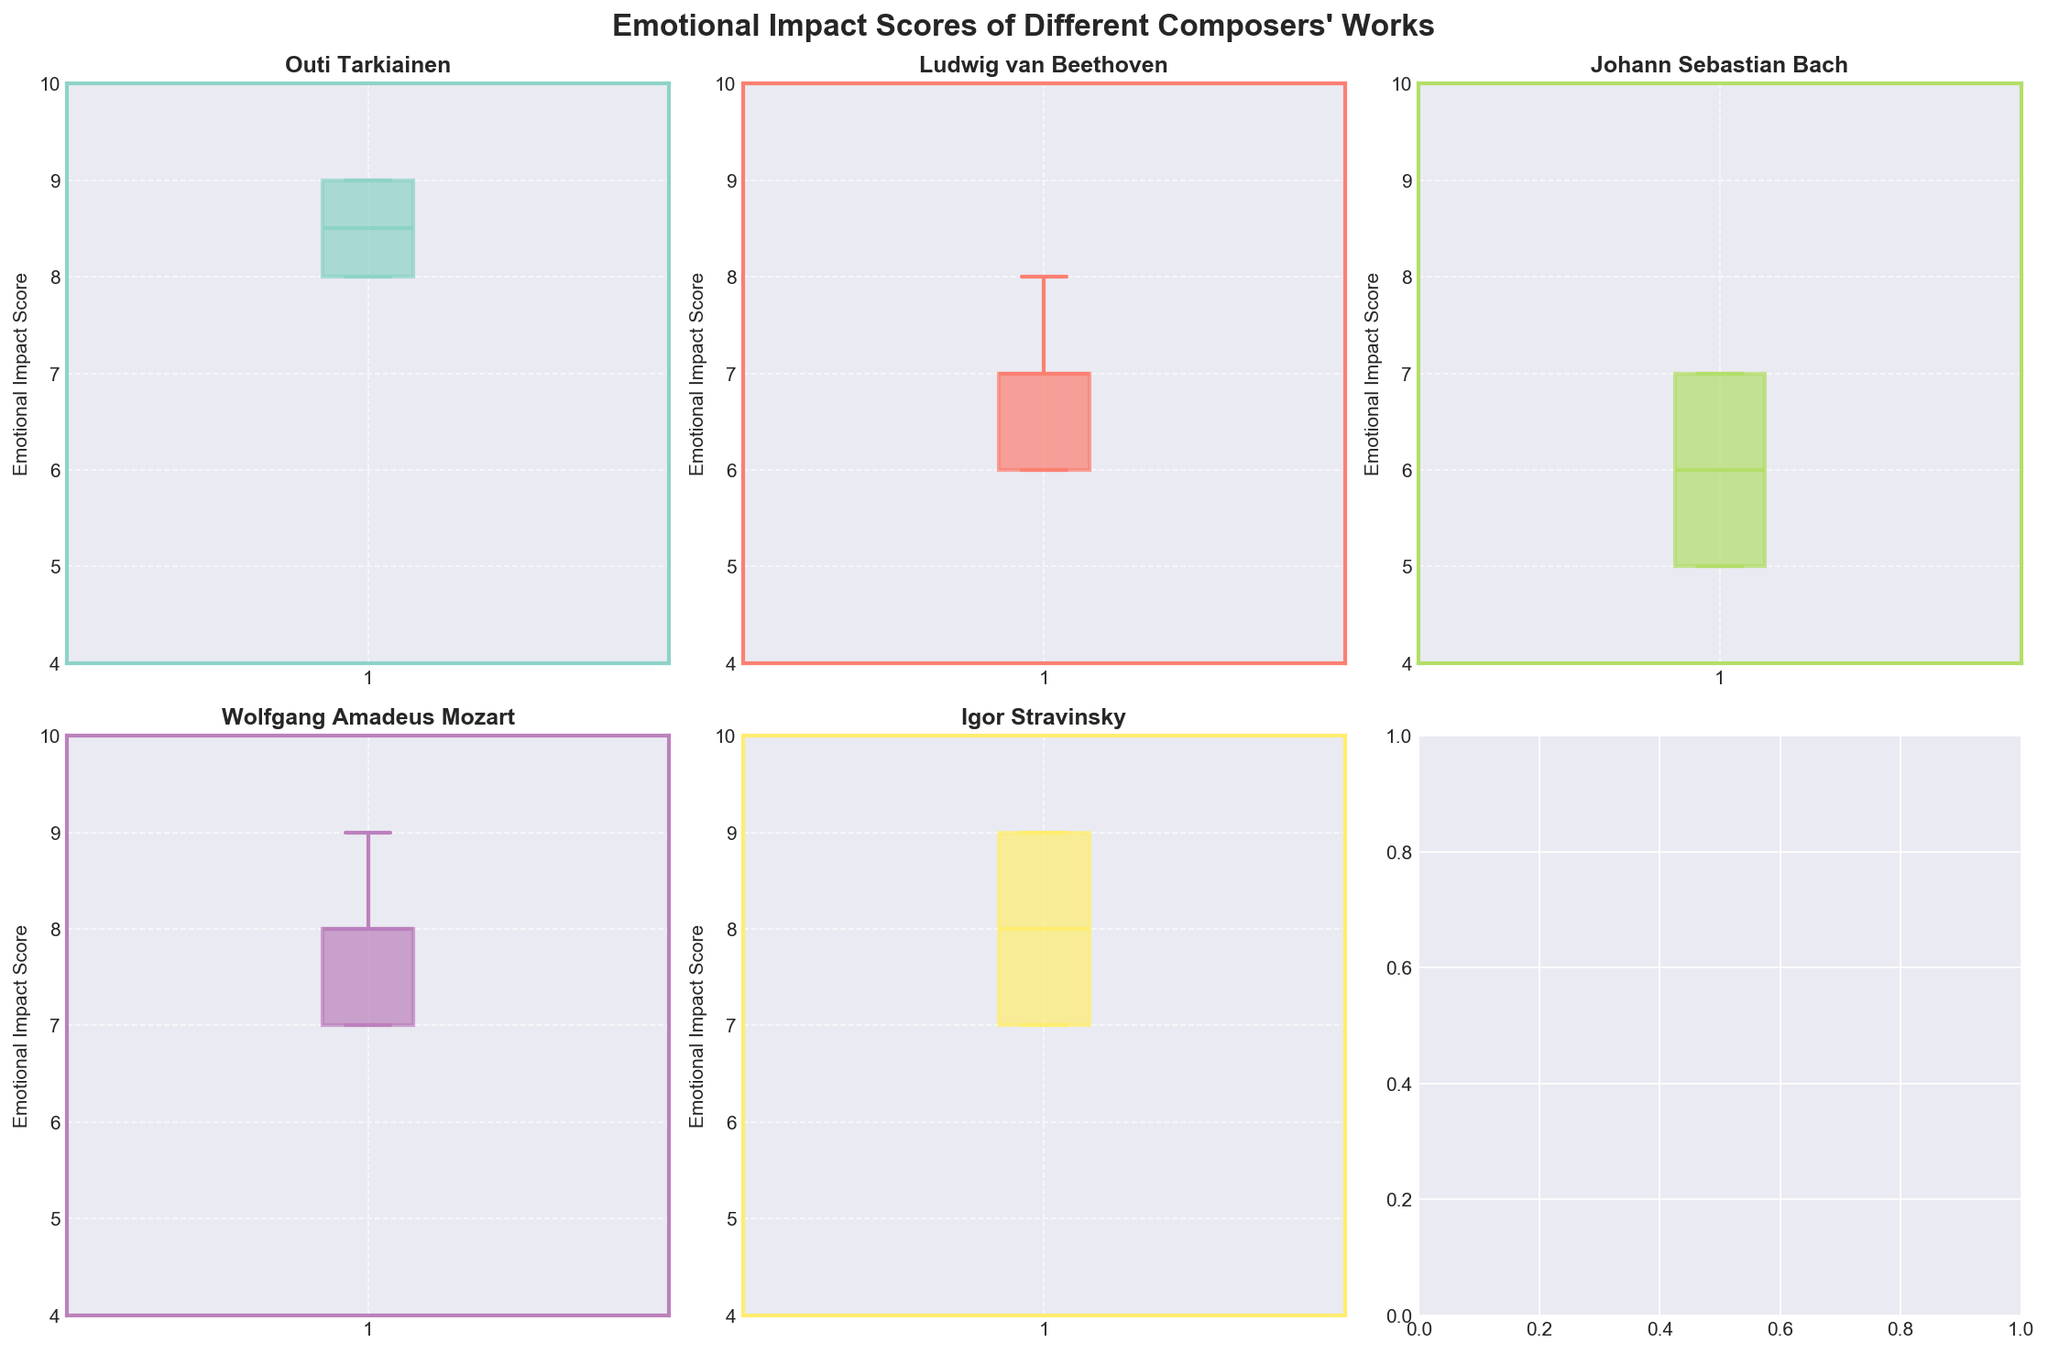What is the title of the figure? The title of the figure is typically found at the top and usually summarizes the primary focus of the figure. In this case, it is a specific case study related to emotional impact scores of works by different composers.
Answer: Emotional Impact Scores of Different Composers' Works Which composer has the highest median emotional impact score? To determine this, examine the median lines in the box plots for each composer. The highest median will be the one that is visually highest on the y-axis.
Answer: Outi Tarkiainen What is the range of emotional impact scores for Johann Sebastian Bach? The range of emotional impact scores is the difference between the maximum and minimum scores in the box plot for Bach.
Answer: 5 - 7 How many unique works are represented in the data for Ludwig van Beethoven? Count the number of unique data points or works listed in the box plot for Beethoven. Each box plot represents a collection of works, and each data point within that plot is a work's emotional impact score.
Answer: 5 Which composer's works have the most consistent emotional impact scores? Consistency can be assessed by the interquartile range (IQR) of the box plots – the smaller the IQR, the more consistent the scores. Check which composer's box plot is narrowest.
Answer: Outi Tarkiainen Does Igor Stravinsky have any outliers in his emotional impact scores? Look for any data points that fall outside the whiskers of Stravinsky's box plot; these are considered outliers.
Answer: No How do the emotional impact scores of Outi Tarkiainen's works compare to those of Wolfgang Amadeus Mozart? Compare the median, IQR, and range of the box plots for Outi Tarkiainen and Mozart to understand their relative emotional impacts.
Answer: Tarkiainen's scores are higher and more consistent, while Mozart has a broader range with a high median What is the median emotional impact score for Wolfgang Amadeus Mozart and Johann Sebastian Bach? Find the median point of the box plots for both Mozart and Bach – this is the line inside the box.
Answer: Mozart: 8, Bach: 6 Which composer has the widest spread of emotional impact scores? Identify the composer with the widest IQR, which is the box part of the plot, indicating the interquartile range.
Answer: Wolfgang Amadeus Mozart 